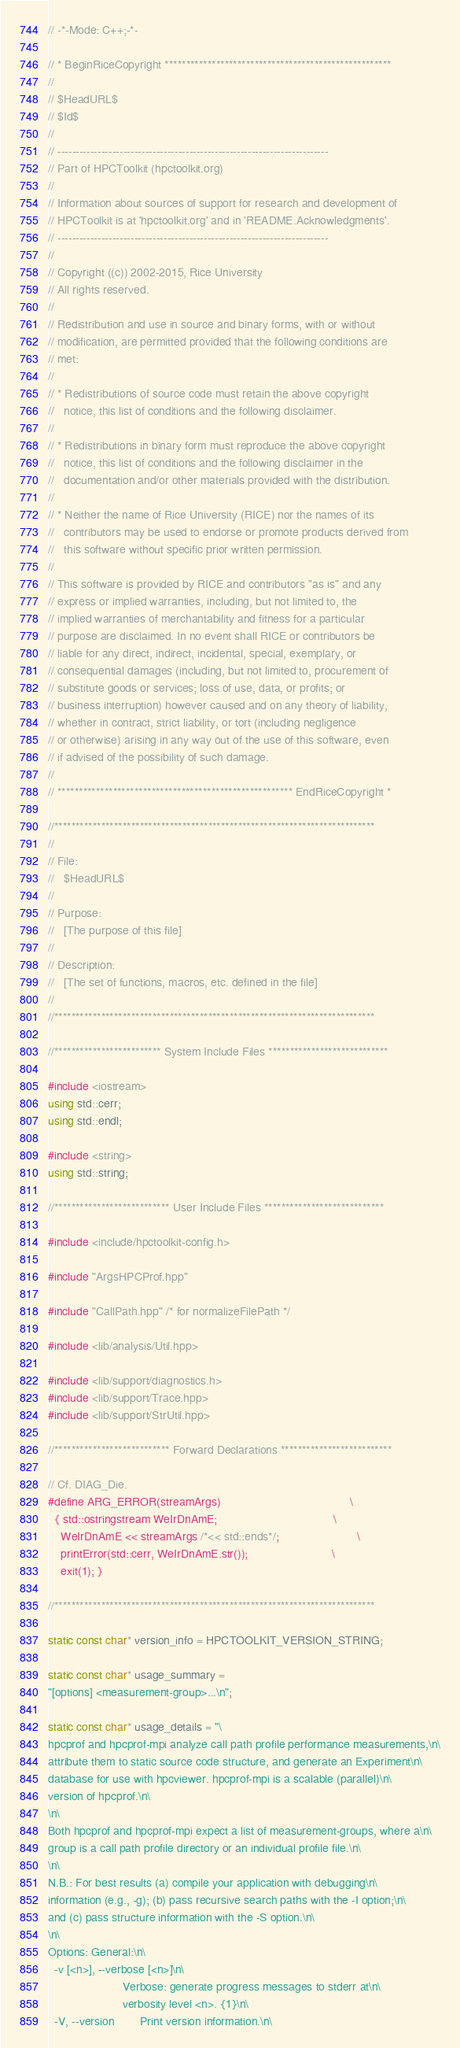Convert code to text. <code><loc_0><loc_0><loc_500><loc_500><_C++_>// -*-Mode: C++;-*-

// * BeginRiceCopyright *****************************************************
//
// $HeadURL$
// $Id$
//
// --------------------------------------------------------------------------
// Part of HPCToolkit (hpctoolkit.org)
//
// Information about sources of support for research and development of
// HPCToolkit is at 'hpctoolkit.org' and in 'README.Acknowledgments'.
// --------------------------------------------------------------------------
//
// Copyright ((c)) 2002-2015, Rice University
// All rights reserved.
//
// Redistribution and use in source and binary forms, with or without
// modification, are permitted provided that the following conditions are
// met:
//
// * Redistributions of source code must retain the above copyright
//   notice, this list of conditions and the following disclaimer.
//
// * Redistributions in binary form must reproduce the above copyright
//   notice, this list of conditions and the following disclaimer in the
//   documentation and/or other materials provided with the distribution.
//
// * Neither the name of Rice University (RICE) nor the names of its
//   contributors may be used to endorse or promote products derived from
//   this software without specific prior written permission.
//
// This software is provided by RICE and contributors "as is" and any
// express or implied warranties, including, but not limited to, the
// implied warranties of merchantability and fitness for a particular
// purpose are disclaimed. In no event shall RICE or contributors be
// liable for any direct, indirect, incidental, special, exemplary, or
// consequential damages (including, but not limited to, procurement of
// substitute goods or services; loss of use, data, or profits; or
// business interruption) however caused and on any theory of liability,
// whether in contract, strict liability, or tort (including negligence
// or otherwise) arising in any way out of the use of this software, even
// if advised of the possibility of such damage.
//
// ******************************************************* EndRiceCopyright *

//***************************************************************************
//
// File:
//   $HeadURL$
//
// Purpose:
//   [The purpose of this file]
//
// Description:
//   [The set of functions, macros, etc. defined in the file]
//
//***************************************************************************

//************************* System Include Files ****************************

#include <iostream>
using std::cerr;
using std::endl;

#include <string>
using std::string;

//*************************** User Include Files ****************************

#include <include/hpctoolkit-config.h>

#include "ArgsHPCProf.hpp"

#include "CallPath.hpp" /* for normalizeFilePath */

#include <lib/analysis/Util.hpp>

#include <lib/support/diagnostics.h>
#include <lib/support/Trace.hpp>
#include <lib/support/StrUtil.hpp>

//*************************** Forward Declarations **************************

// Cf. DIAG_Die.
#define ARG_ERROR(streamArgs)                                        \
  { std::ostringstream WeIrDnAmE;                                    \
    WeIrDnAmE << streamArgs /*<< std::ends*/;                        \
    printError(std::cerr, WeIrDnAmE.str());                          \
    exit(1); }

//***************************************************************************

static const char* version_info = HPCTOOLKIT_VERSION_STRING;

static const char* usage_summary =
"[options] <measurement-group>...\n";

static const char* usage_details = "\
hpcprof and hpcprof-mpi analyze call path profile performance measurements,\n\
attribute them to static source code structure, and generate an Experiment\n\
database for use with hpcviewer. hpcprof-mpi is a scalable (parallel)\n\
version of hpcprof.\n\
\n\
Both hpcprof and hpcprof-mpi expect a list of measurement-groups, where a\n\
group is a call path profile directory or an individual profile file.\n\
\n\
N.B.: For best results (a) compile your application with debugging\n\
information (e.g., -g); (b) pass recursive search paths with the -I option;\n\
and (c) pass structure information with the -S option.\n\
\n\
Options: General:\n\
  -v [<n>], --verbose [<n>]\n\
                       Verbose: generate progress messages to stderr at\n\
                       verbosity level <n>. {1}\n\
  -V, --version        Print version information.\n\</code> 